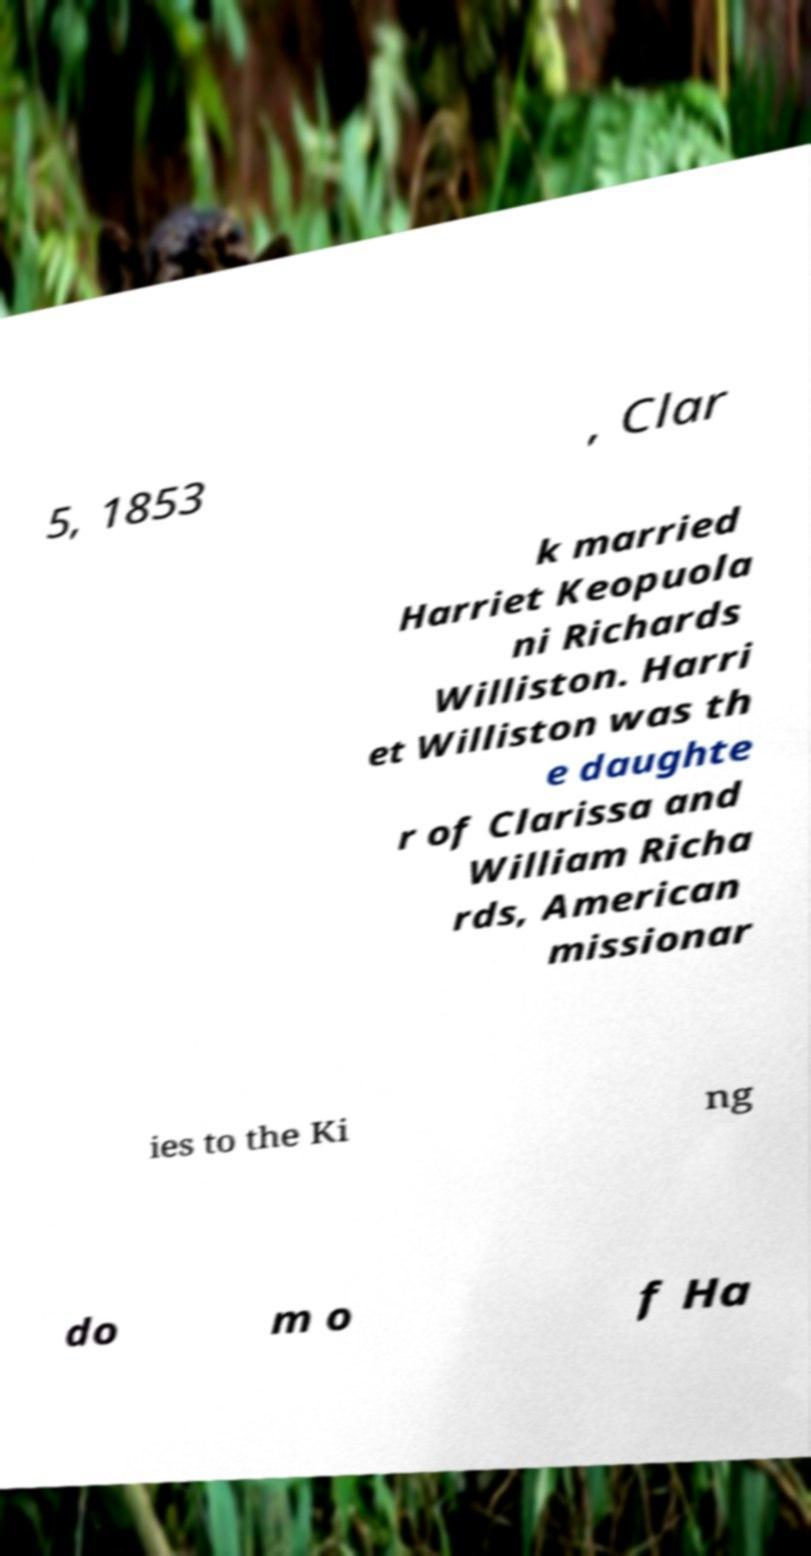What messages or text are displayed in this image? I need them in a readable, typed format. 5, 1853 , Clar k married Harriet Keopuola ni Richards Williston. Harri et Williston was th e daughte r of Clarissa and William Richa rds, American missionar ies to the Ki ng do m o f Ha 